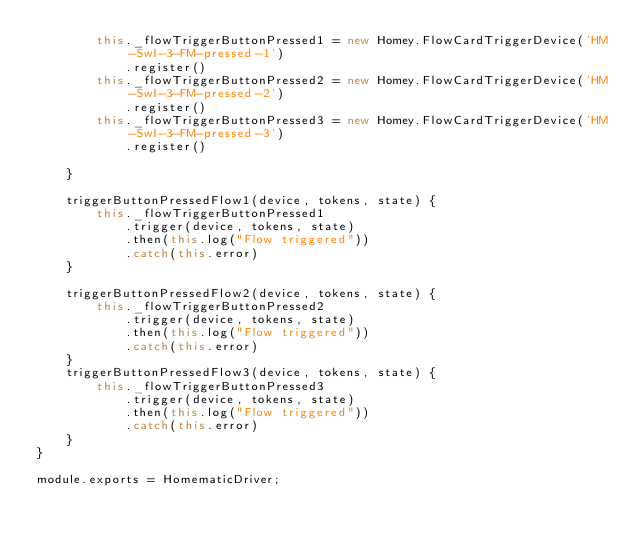<code> <loc_0><loc_0><loc_500><loc_500><_JavaScript_>        this._flowTriggerButtonPressed1 = new Homey.FlowCardTriggerDevice('HM-SwI-3-FM-pressed-1')
            .register()
        this._flowTriggerButtonPressed2 = new Homey.FlowCardTriggerDevice('HM-SwI-3-FM-pressed-2')
            .register()
        this._flowTriggerButtonPressed3 = new Homey.FlowCardTriggerDevice('HM-SwI-3-FM-pressed-3')
            .register()

    }

    triggerButtonPressedFlow1(device, tokens, state) {
        this._flowTriggerButtonPressed1
            .trigger(device, tokens, state)
            .then(this.log("Flow triggered"))
            .catch(this.error)
    }

    triggerButtonPressedFlow2(device, tokens, state) {
        this._flowTriggerButtonPressed2
            .trigger(device, tokens, state)
            .then(this.log("Flow triggered"))
            .catch(this.error)
    }
    triggerButtonPressedFlow3(device, tokens, state) {
        this._flowTriggerButtonPressed3
            .trigger(device, tokens, state)
            .then(this.log("Flow triggered"))
            .catch(this.error)
    }
}

module.exports = HomematicDriver;</code> 